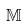<formula> <loc_0><loc_0><loc_500><loc_500>\mathbb { M }</formula> 